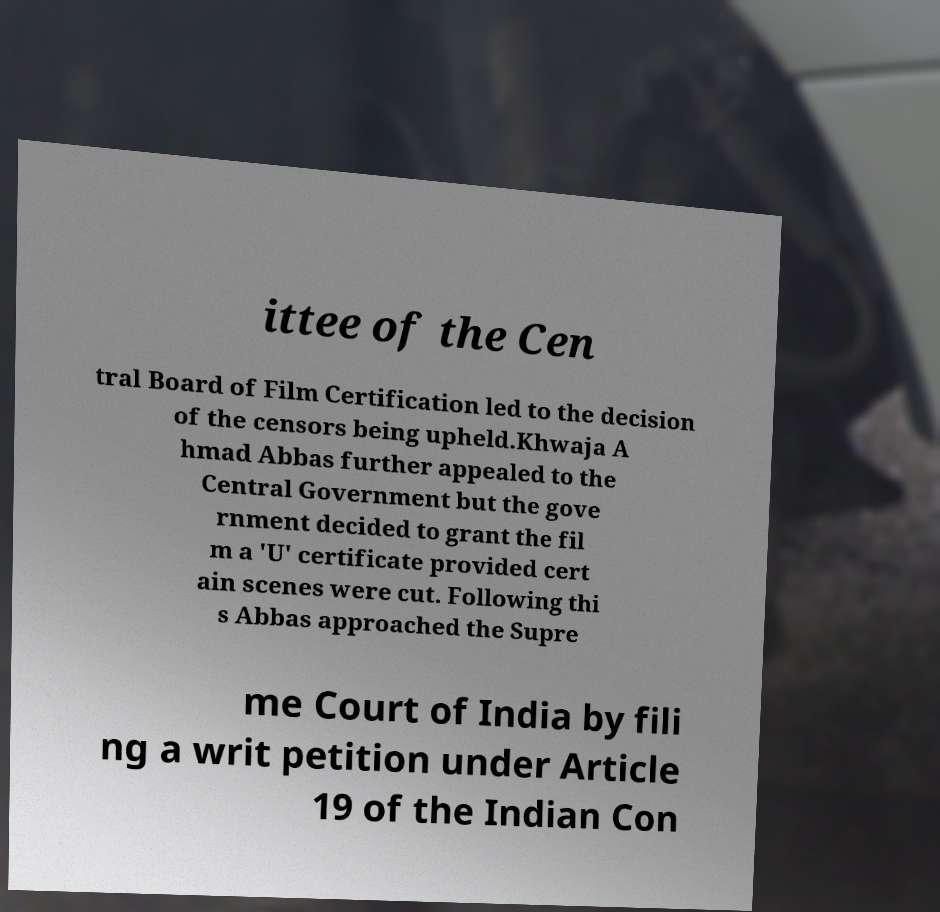Could you assist in decoding the text presented in this image and type it out clearly? ittee of the Cen tral Board of Film Certification led to the decision of the censors being upheld.Khwaja A hmad Abbas further appealed to the Central Government but the gove rnment decided to grant the fil m a 'U' certificate provided cert ain scenes were cut. Following thi s Abbas approached the Supre me Court of India by fili ng a writ petition under Article 19 of the Indian Con 